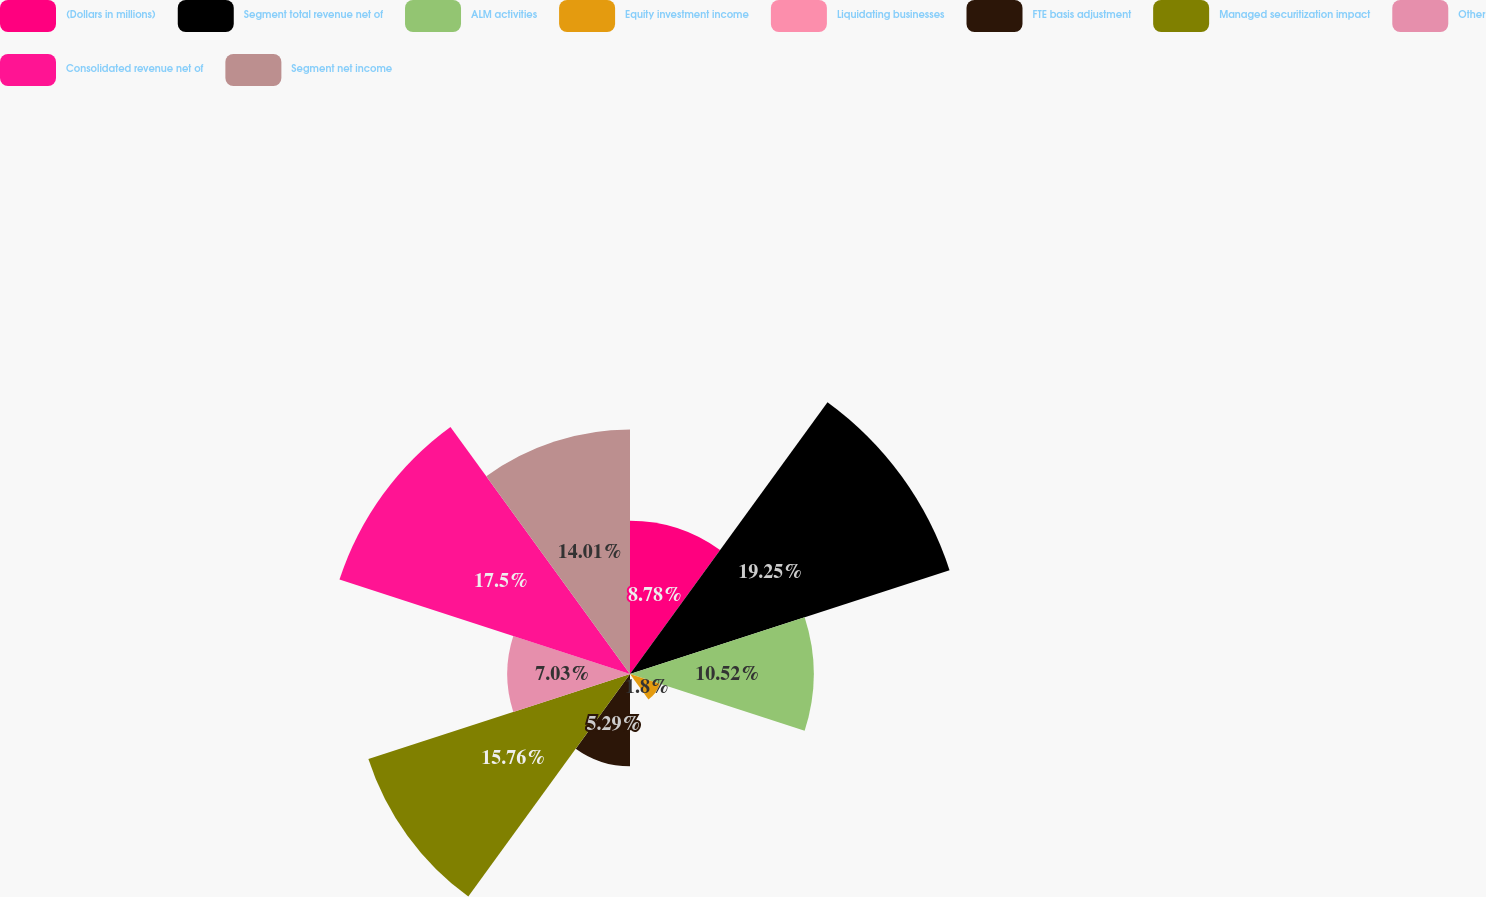<chart> <loc_0><loc_0><loc_500><loc_500><pie_chart><fcel>(Dollars in millions)<fcel>Segment total revenue net of<fcel>ALM activities<fcel>Equity investment income<fcel>Liquidating businesses<fcel>FTE basis adjustment<fcel>Managed securitization impact<fcel>Other<fcel>Consolidated revenue net of<fcel>Segment net income<nl><fcel>8.78%<fcel>19.25%<fcel>10.52%<fcel>1.8%<fcel>0.06%<fcel>5.29%<fcel>15.76%<fcel>7.03%<fcel>17.5%<fcel>14.01%<nl></chart> 